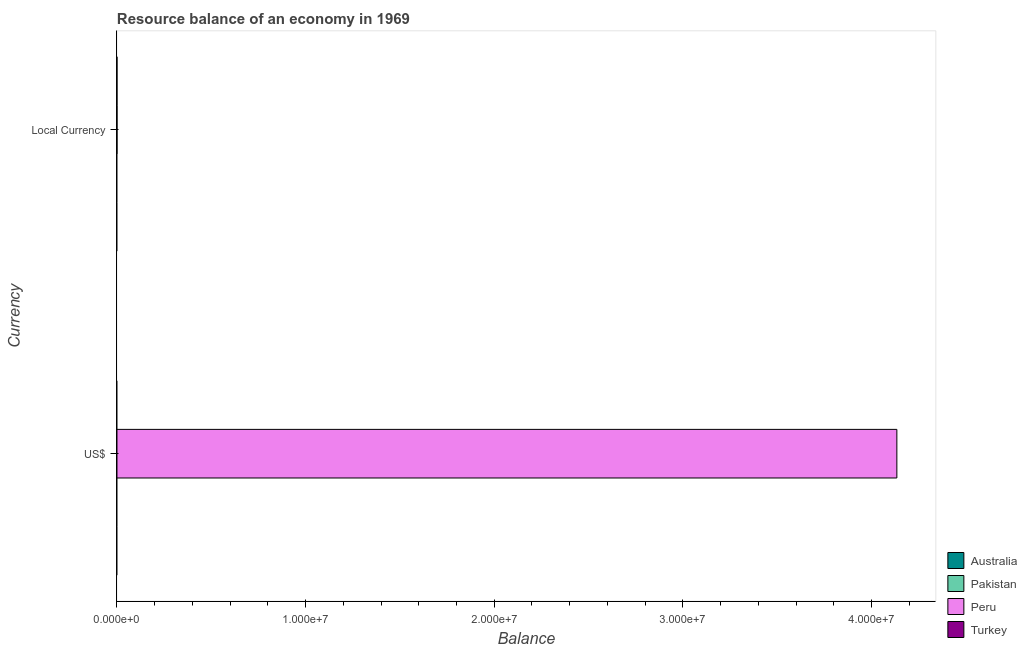How many different coloured bars are there?
Your answer should be compact. 1. Are the number of bars per tick equal to the number of legend labels?
Provide a short and direct response. No. How many bars are there on the 1st tick from the top?
Offer a very short reply. 1. How many bars are there on the 1st tick from the bottom?
Offer a terse response. 1. What is the label of the 1st group of bars from the top?
Your answer should be very brief. Local Currency. What is the resource balance in constant us$ in Peru?
Provide a succinct answer. 1.6. Across all countries, what is the maximum resource balance in constant us$?
Ensure brevity in your answer.  1.6. In which country was the resource balance in us$ maximum?
Offer a very short reply. Peru. What is the total resource balance in us$ in the graph?
Keep it short and to the point. 4.13e+07. What is the difference between the resource balance in constant us$ in Pakistan and the resource balance in us$ in Australia?
Make the answer very short. 0. What is the average resource balance in us$ per country?
Give a very brief answer. 1.03e+07. What is the difference between the resource balance in us$ and resource balance in constant us$ in Peru?
Your answer should be very brief. 4.13e+07. In how many countries, is the resource balance in constant us$ greater than the average resource balance in constant us$ taken over all countries?
Your answer should be compact. 1. How many bars are there?
Provide a succinct answer. 2. How many countries are there in the graph?
Offer a very short reply. 4. What is the difference between two consecutive major ticks on the X-axis?
Make the answer very short. 1.00e+07. Are the values on the major ticks of X-axis written in scientific E-notation?
Offer a very short reply. Yes. Does the graph contain any zero values?
Offer a terse response. Yes. Where does the legend appear in the graph?
Offer a terse response. Bottom right. How are the legend labels stacked?
Keep it short and to the point. Vertical. What is the title of the graph?
Offer a terse response. Resource balance of an economy in 1969. Does "Hungary" appear as one of the legend labels in the graph?
Offer a very short reply. No. What is the label or title of the X-axis?
Ensure brevity in your answer.  Balance. What is the label or title of the Y-axis?
Keep it short and to the point. Currency. What is the Balance in Peru in US$?
Ensure brevity in your answer.  4.13e+07. What is the Balance of Turkey in US$?
Offer a terse response. 0. What is the Balance in Australia in Local Currency?
Your answer should be compact. 0. What is the Balance in Pakistan in Local Currency?
Your answer should be compact. 0. What is the Balance of Peru in Local Currency?
Your answer should be very brief. 1.6. Across all Currency, what is the maximum Balance of Peru?
Keep it short and to the point. 4.13e+07. Across all Currency, what is the minimum Balance in Peru?
Your answer should be very brief. 1.6. What is the total Balance of Peru in the graph?
Your response must be concise. 4.13e+07. What is the total Balance of Turkey in the graph?
Give a very brief answer. 0. What is the difference between the Balance in Peru in US$ and that in Local Currency?
Give a very brief answer. 4.13e+07. What is the average Balance of Australia per Currency?
Offer a very short reply. 0. What is the average Balance of Peru per Currency?
Your answer should be very brief. 2.07e+07. What is the ratio of the Balance in Peru in US$ to that in Local Currency?
Offer a very short reply. 2.58e+07. What is the difference between the highest and the second highest Balance in Peru?
Provide a succinct answer. 4.13e+07. What is the difference between the highest and the lowest Balance of Peru?
Give a very brief answer. 4.13e+07. 